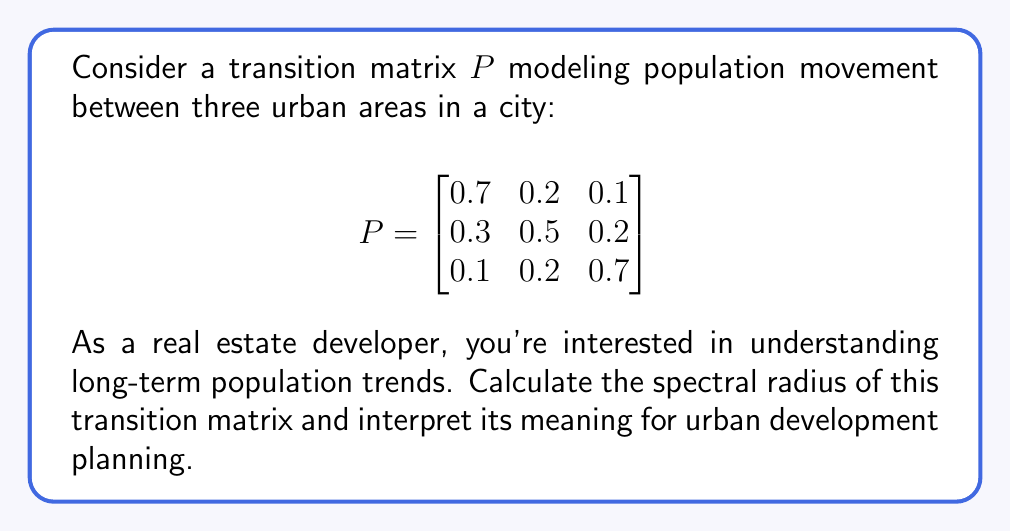Show me your answer to this math problem. 1) To find the spectral radius, we need to calculate the eigenvalues of $P$.

2) The characteristic equation is:
   $$\det(P - \lambda I) = 0$$
   
   $$\begin{vmatrix}
   0.7-\lambda & 0.2 & 0.1 \\
   0.3 & 0.5-\lambda & 0.2 \\
   0.1 & 0.2 & 0.7-\lambda
   \end{vmatrix} = 0$$

3) Expanding the determinant:
   $$(0.7-\lambda)[(0.5-\lambda)(0.7-\lambda)-0.04] - 0.2[0.3(0.7-\lambda)-0.02] + 0.1[0.06-0.3(0.5-\lambda)] = 0$$

4) Simplifying:
   $$-\lambda^3 + 1.9\lambda^2 - 0.9\lambda = 0$$
   $$\lambda(-\lambda^2 + 1.9\lambda - 0.9) = 0$$

5) Solving this equation:
   $\lambda_1 = 0$
   $\lambda_2 = 1$
   $\lambda_3 = 0.9$

6) The spectral radius is the largest absolute eigenvalue:
   $$\rho(P) = \max(|\lambda_1|, |\lambda_2|, |\lambda_3|) = 1$$

7) Interpretation: The spectral radius of 1 indicates that the population distribution will converge to a stable state over time. This means that, in the long run, the relative populations of the three urban areas will reach an equilibrium, regardless of the initial distribution.

For a real estate developer, this suggests that while short-term fluctuations may occur, the long-term population distribution across these urban areas will stabilize. This information can inform decisions about where and when to develop properties, balancing immediate financial gains with long-term community needs and growth patterns.
Answer: $\rho(P) = 1$, indicating long-term population stability across urban areas. 